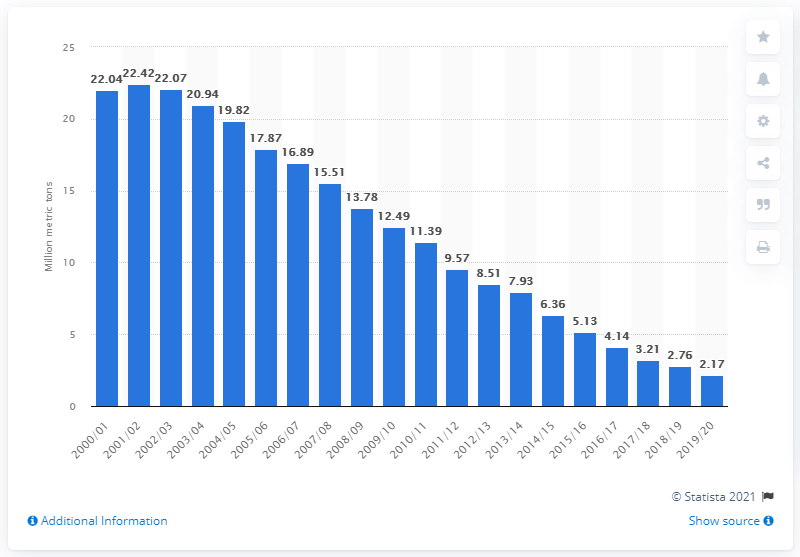Identify some key points in this picture. The amount of waste collected by local authorities for landfills for the year ended March 2020 was 2.17 million metric tons. 